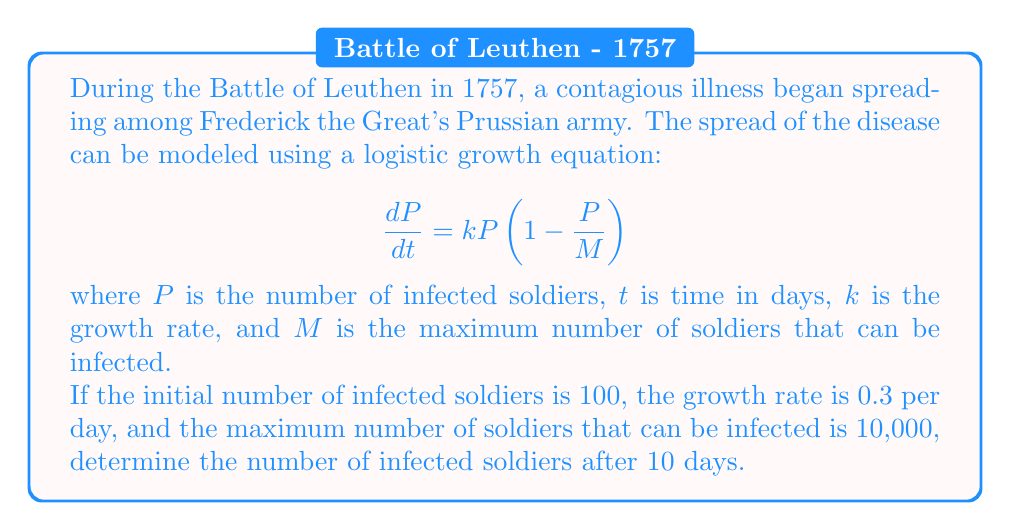Could you help me with this problem? To solve this problem, we need to use the solution to the logistic differential equation:

$$P(t) = \frac{M}{1 + (\frac{M}{P_0} - 1)e^{-kt}}$$

Where:
$P(t)$ is the number of infected soldiers at time $t$
$M$ is the maximum number of soldiers that can be infected (10,000)
$P_0$ is the initial number of infected soldiers (100)
$k$ is the growth rate (0.3 per day)
$t$ is the time in days (10)

Let's substitute these values into the equation:

$$P(10) = \frac{10000}{1 + (\frac{10000}{100} - 1)e^{-0.3 \cdot 10}}$$

$$= \frac{10000}{1 + (100 - 1)e^{-3}}$$

$$= \frac{10000}{1 + 99e^{-3}}$$

Now, let's calculate this step by step:

1. Calculate $e^{-3} \approx 0.0498$
2. Multiply: $99 \cdot 0.0498 \approx 4.9302$
3. Add 1: $1 + 4.9302 = 5.9302$
4. Divide: $10000 \div 5.9302 \approx 1686.13$

Rounding to the nearest whole number (as we can't have a fraction of an infected soldier), we get 1686 infected soldiers after 10 days.
Answer: 1686 infected soldiers 